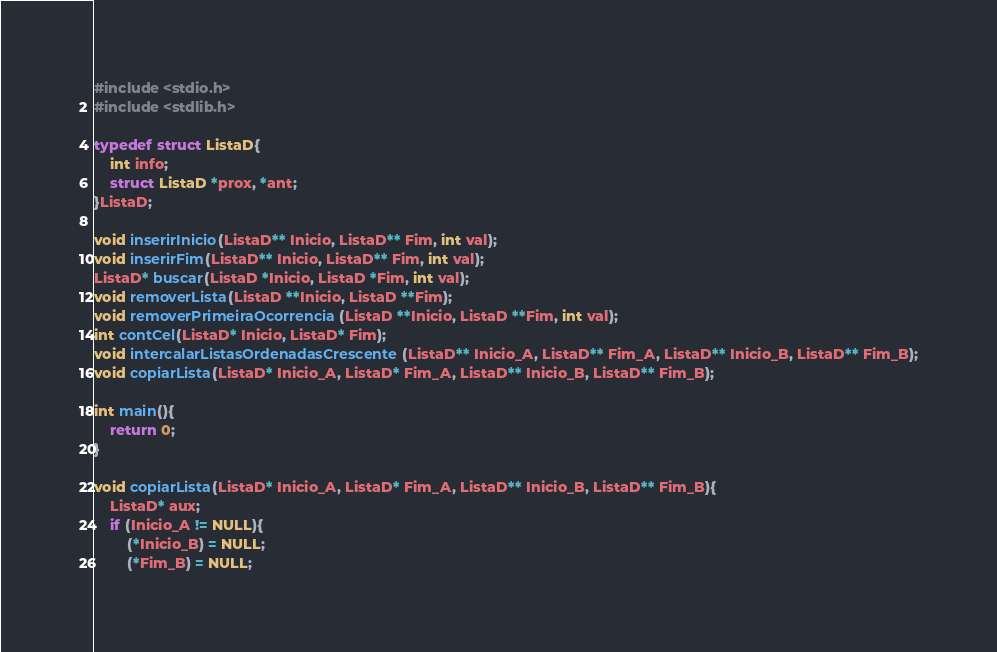<code> <loc_0><loc_0><loc_500><loc_500><_C++_>#include <stdio.h>
#include <stdlib.h>

typedef struct ListaD{ 
	int info; 
	struct ListaD *prox, *ant; 
}ListaD; 

void inserirInicio(ListaD** Inicio, ListaD** Fim, int val);
void inserirFim(ListaD** Inicio, ListaD** Fim, int val);
ListaD* buscar(ListaD *Inicio, ListaD *Fim, int val);
void removerLista(ListaD **Inicio, ListaD **Fim);
void removerPrimeiraOcorrencia(ListaD **Inicio, ListaD **Fim, int val);
int contCel(ListaD* Inicio, ListaD* Fim);
void intercalarListasOrdenadasCrescente(ListaD** Inicio_A, ListaD** Fim_A, ListaD** Inicio_B, ListaD** Fim_B);
void copiarLista(ListaD* Inicio_A, ListaD* Fim_A, ListaD** Inicio_B, ListaD** Fim_B);

int main(){
	return 0;
}

void copiarLista(ListaD* Inicio_A, ListaD* Fim_A, ListaD** Inicio_B, ListaD** Fim_B){
	ListaD* aux;
	if (Inicio_A != NULL){
		(*Inicio_B) = NULL;
		(*Fim_B) = NULL;</code> 